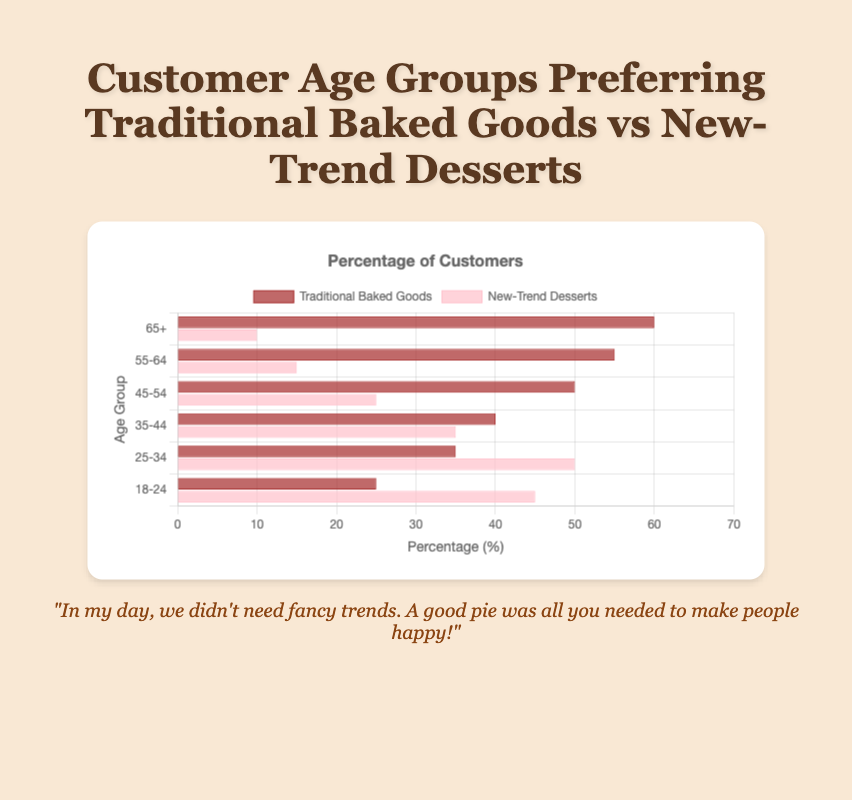What's the most preferred dessert type among the age group 65+? The horizontal bars show that people aged 65+ prefer traditional baked goods more, with 60% for traditional baked goods and 10% for new-trend desserts.
Answer: Traditional baked goods Which age group has the closest preference percentage for traditional baked goods and new-trend desserts? Observing the bars, the age group 35-44 has 40% for traditional baked goods and 35% for new-trend desserts, which are the closest to each other.
Answer: 35-44 Between the age groups 18-24 and 45-54, which group shows a stronger preference for traditional baked goods compared to new-trend desserts? The 45-54 age group has 50% preference for traditional baked goods and 25% for new-trend desserts, while the 18-24 group has 25% for traditional and 45% for new-trend. Thus, the 45-54 group shows a stronger preference for traditional baked goods.
Answer: 45-54 What's the average preference percentage for new-trend desserts in the age groups 25-34 and 35-44? The preference percentages for new-trend desserts are 50% for 25-34 and 35% for 35-44. Calculating the average: (50 + 35) / 2 = 42.5%.
Answer: 42.5% In which age group is the preference for new-trend desserts least popular? Observing the horizontal bars, the 65+ group shows the least preference for new-trend desserts with only 10%.
Answer: 65+ Compare the preference percentages for traditional baked goods between the age groups 55-64 and 65+. Which group has a higher preference? The horizontal bars show that the 65+ group has a 60% preference for traditional baked goods, while the 55-64 group has 55%. Therefore, the 65+ group has a higher preference for traditional baked goods.
Answer: 65+ What is the total preference percentage for traditional baked goods among the age groups 18-24, 25-34, and 35-44? Summing up the preferences for traditional baked goods in these groups gives: 25 + 35 + 40 = 100%.
Answer: 100% Which age group's bar for new-trend desserts is nearly half of the bar for traditional baked goods in the same group? The 45-54 age group has 50% for traditional baked goods and 25% for new-trend desserts, where 25% is nearly half of 50%.
Answer: 45-54 